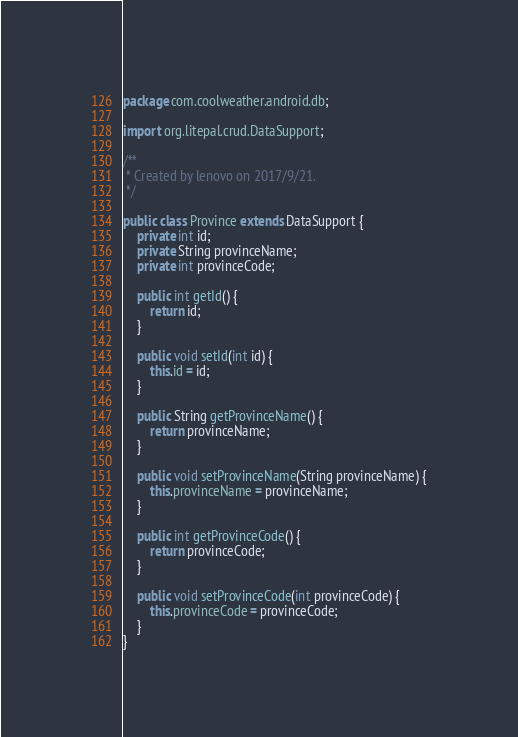<code> <loc_0><loc_0><loc_500><loc_500><_Java_>package com.coolweather.android.db;

import org.litepal.crud.DataSupport;

/**
 * Created by lenovo on 2017/9/21.
 */

public class Province extends DataSupport {
    private int id;
    private String provinceName;
    private int provinceCode;

    public int getId() {
        return id;
    }

    public void setId(int id) {
        this.id = id;
    }

    public String getProvinceName() {
        return provinceName;
    }

    public void setProvinceName(String provinceName) {
        this.provinceName = provinceName;
    }

    public int getProvinceCode() {
        return provinceCode;
    }

    public void setProvinceCode(int provinceCode) {
        this.provinceCode = provinceCode;
    }
}
</code> 